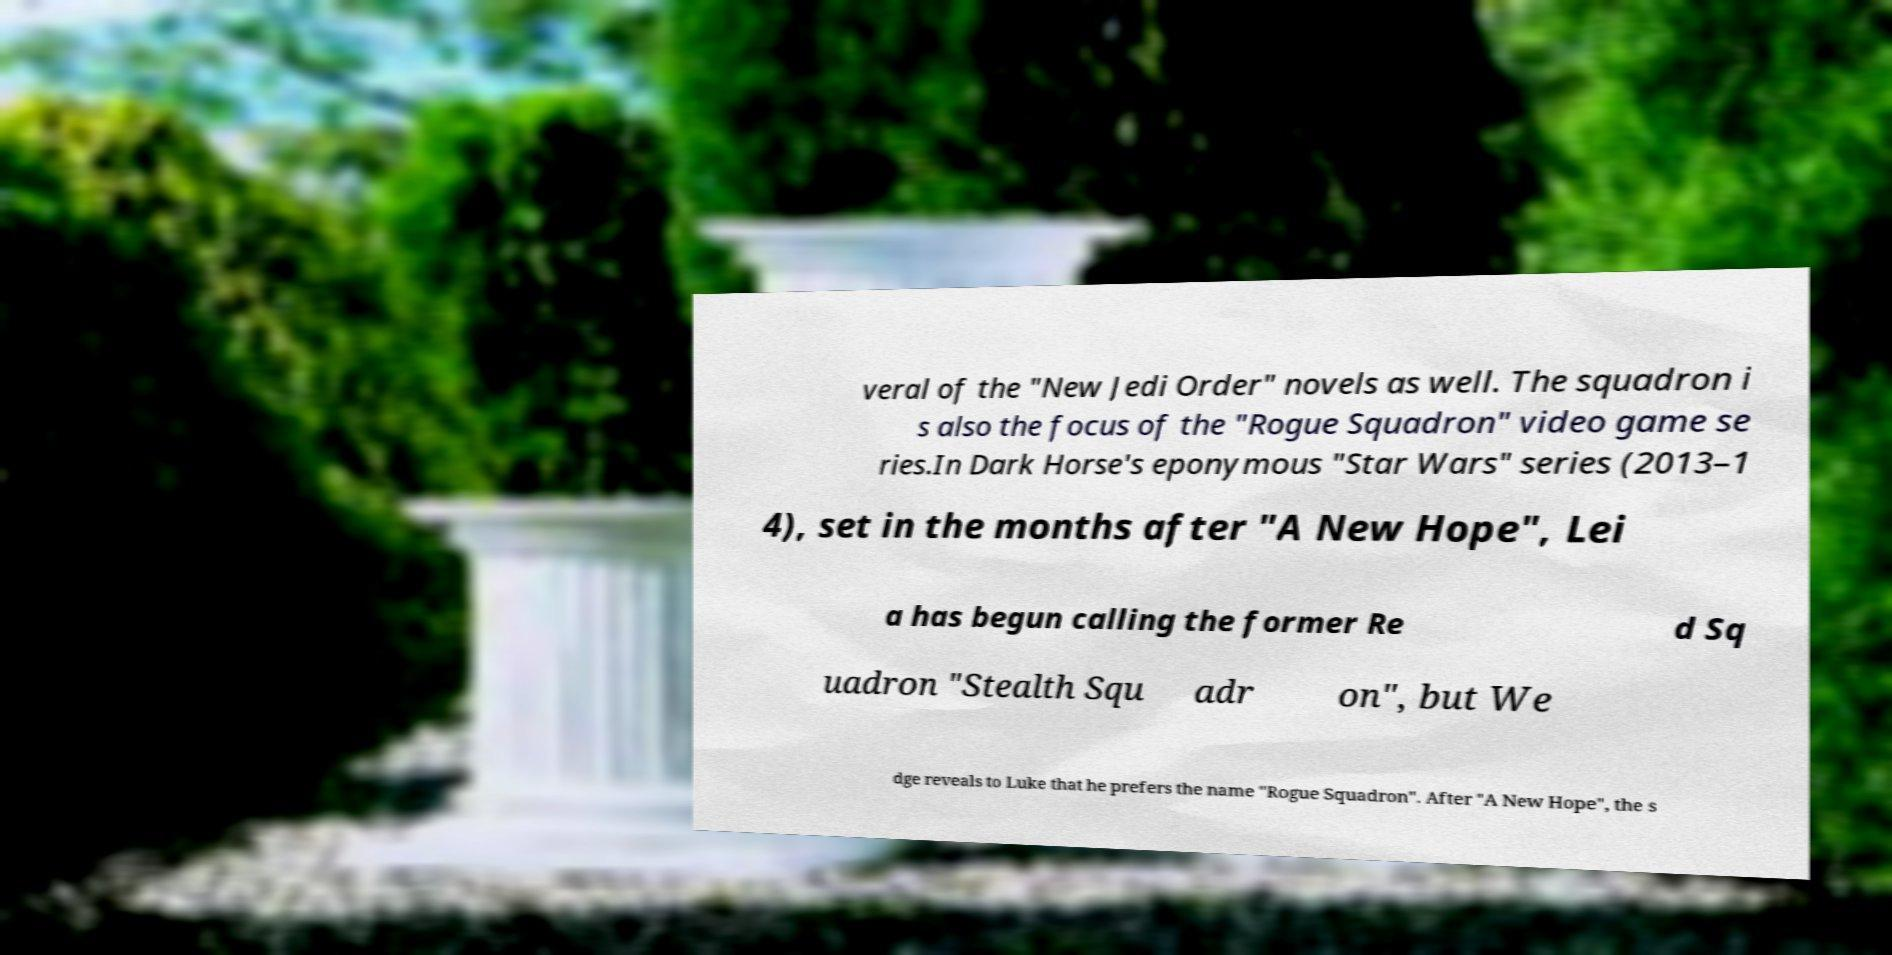Can you read and provide the text displayed in the image?This photo seems to have some interesting text. Can you extract and type it out for me? veral of the "New Jedi Order" novels as well. The squadron i s also the focus of the "Rogue Squadron" video game se ries.In Dark Horse's eponymous "Star Wars" series (2013–1 4), set in the months after "A New Hope", Lei a has begun calling the former Re d Sq uadron "Stealth Squ adr on", but We dge reveals to Luke that he prefers the name "Rogue Squadron". After "A New Hope", the s 